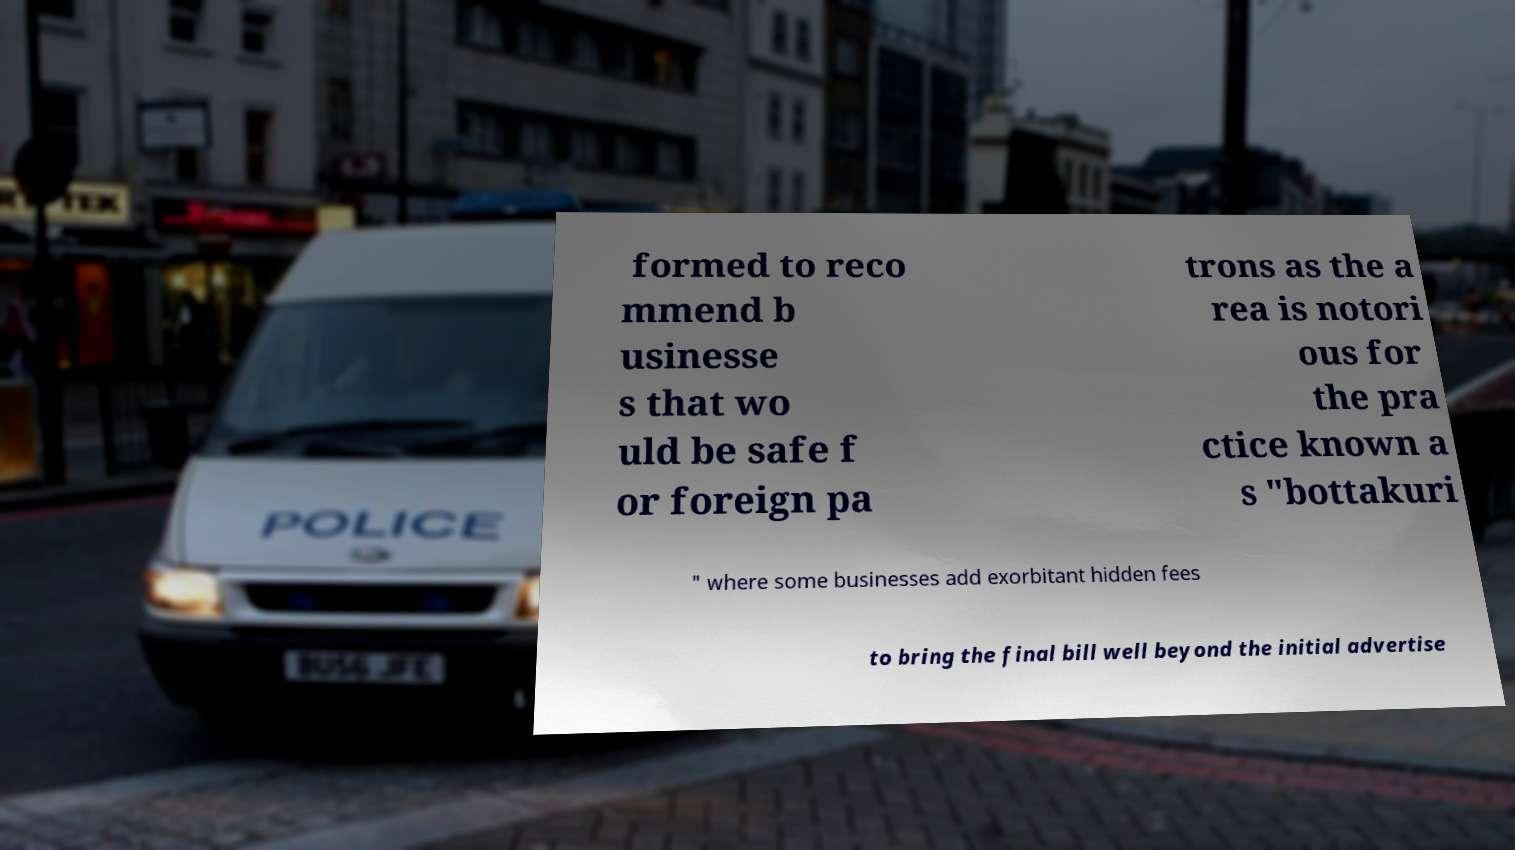Please read and relay the text visible in this image. What does it say? formed to reco mmend b usinesse s that wo uld be safe f or foreign pa trons as the a rea is notori ous for the pra ctice known a s "bottakuri " where some businesses add exorbitant hidden fees to bring the final bill well beyond the initial advertise 